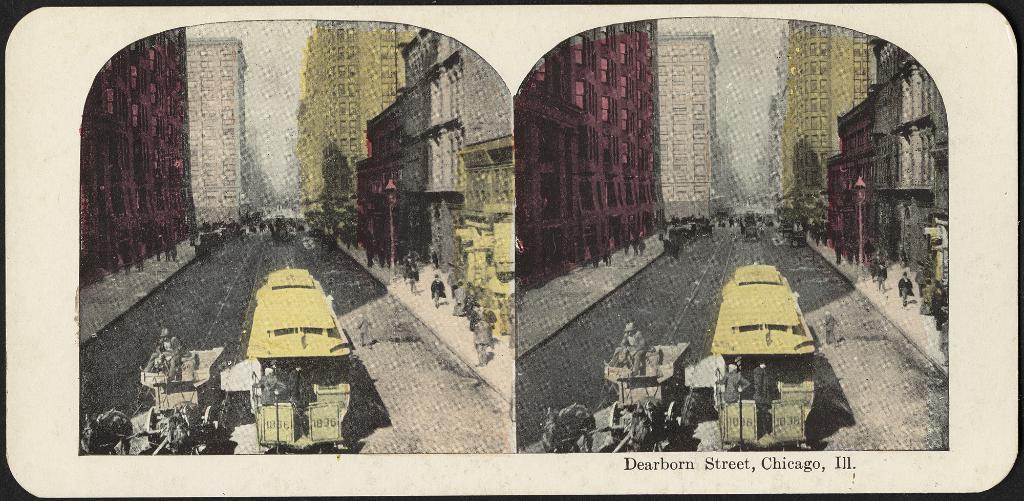How would you summarize this image in a sentence or two? This is a collage image as we can see there is a bus in the bottom of this image and there are some persons standing in the background. There are some buildings on the top of this image. There is one man is riding on horse in the bottom left side of this image, and there are some persons standing on the right side of this image. 